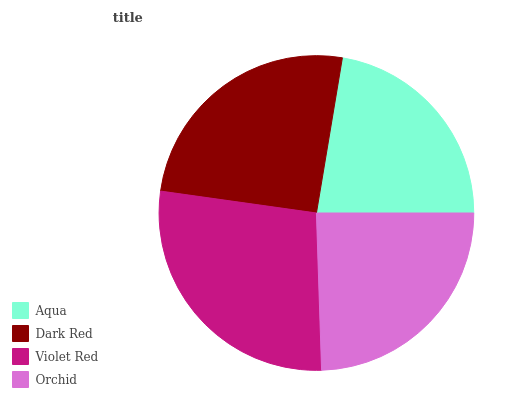Is Aqua the minimum?
Answer yes or no. Yes. Is Violet Red the maximum?
Answer yes or no. Yes. Is Dark Red the minimum?
Answer yes or no. No. Is Dark Red the maximum?
Answer yes or no. No. Is Dark Red greater than Aqua?
Answer yes or no. Yes. Is Aqua less than Dark Red?
Answer yes or no. Yes. Is Aqua greater than Dark Red?
Answer yes or no. No. Is Dark Red less than Aqua?
Answer yes or no. No. Is Dark Red the high median?
Answer yes or no. Yes. Is Orchid the low median?
Answer yes or no. Yes. Is Aqua the high median?
Answer yes or no. No. Is Aqua the low median?
Answer yes or no. No. 